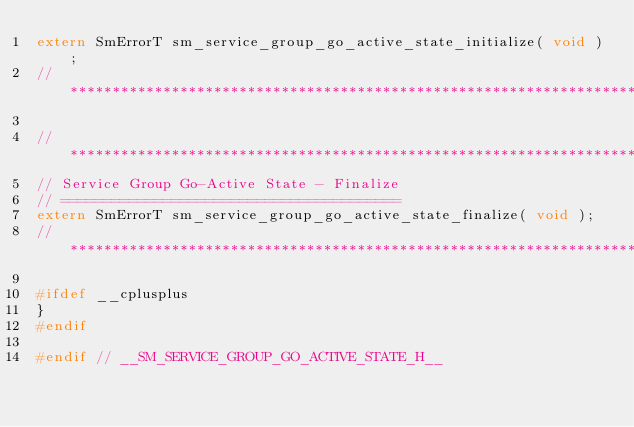Convert code to text. <code><loc_0><loc_0><loc_500><loc_500><_C_>extern SmErrorT sm_service_group_go_active_state_initialize( void );
// ****************************************************************************

// ****************************************************************************
// Service Group Go-Active State - Finalize
// ========================================
extern SmErrorT sm_service_group_go_active_state_finalize( void );
// ****************************************************************************

#ifdef __cplusplus
}
#endif

#endif // __SM_SERVICE_GROUP_GO_ACTIVE_STATE_H__
</code> 